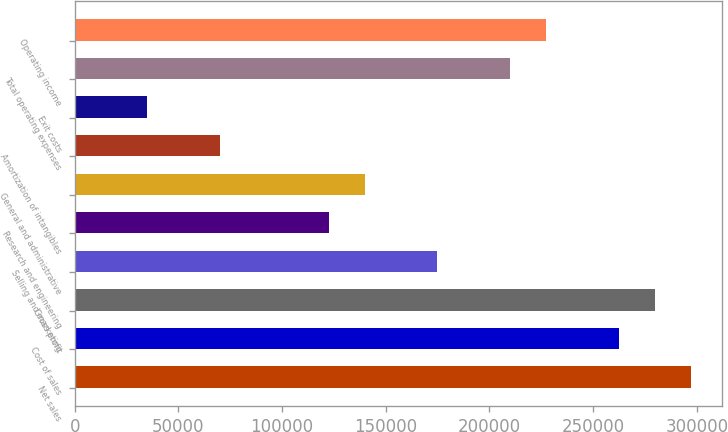Convert chart. <chart><loc_0><loc_0><loc_500><loc_500><bar_chart><fcel>Net sales<fcel>Cost of sales<fcel>Gross profit<fcel>Selling and marketing<fcel>Research and engineering<fcel>General and administrative<fcel>Amortization of intangibles<fcel>Exit costs<fcel>Total operating expenses<fcel>Operating income<nl><fcel>297282<fcel>262308<fcel>279795<fcel>174874<fcel>122413<fcel>139900<fcel>69952.6<fcel>34978.8<fcel>209848<fcel>227335<nl></chart> 